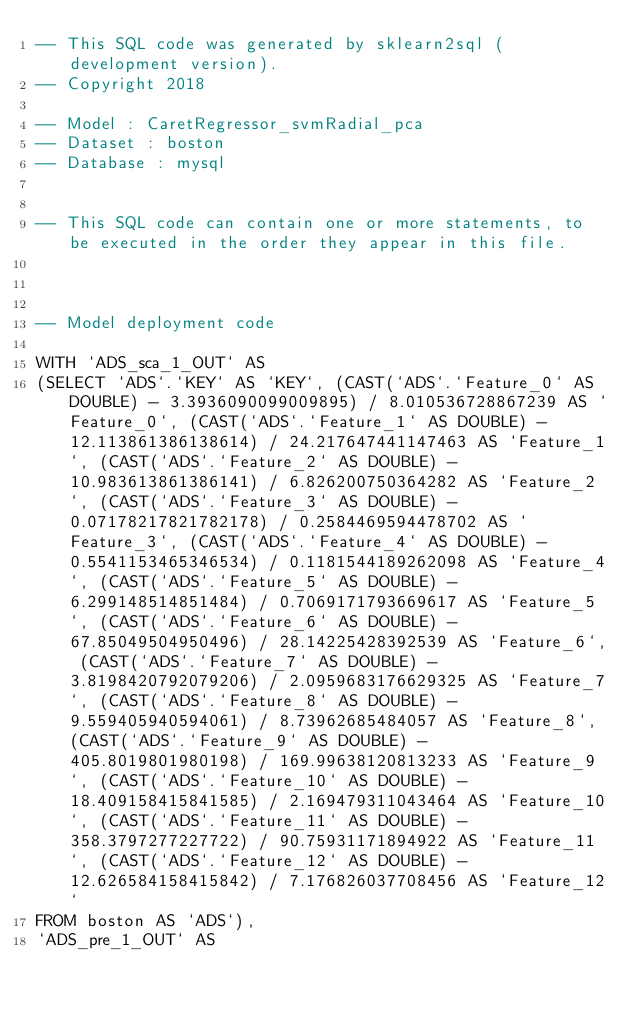Convert code to text. <code><loc_0><loc_0><loc_500><loc_500><_SQL_>-- This SQL code was generated by sklearn2sql (development version).
-- Copyright 2018

-- Model : CaretRegressor_svmRadial_pca
-- Dataset : boston
-- Database : mysql


-- This SQL code can contain one or more statements, to be executed in the order they appear in this file.



-- Model deployment code

WITH `ADS_sca_1_OUT` AS 
(SELECT `ADS`.`KEY` AS `KEY`, (CAST(`ADS`.`Feature_0` AS DOUBLE) - 3.3936090099009895) / 8.010536728867239 AS `Feature_0`, (CAST(`ADS`.`Feature_1` AS DOUBLE) - 12.113861386138614) / 24.217647441147463 AS `Feature_1`, (CAST(`ADS`.`Feature_2` AS DOUBLE) - 10.983613861386141) / 6.826200750364282 AS `Feature_2`, (CAST(`ADS`.`Feature_3` AS DOUBLE) - 0.07178217821782178) / 0.2584469594478702 AS `Feature_3`, (CAST(`ADS`.`Feature_4` AS DOUBLE) - 0.5541153465346534) / 0.1181544189262098 AS `Feature_4`, (CAST(`ADS`.`Feature_5` AS DOUBLE) - 6.299148514851484) / 0.7069171793669617 AS `Feature_5`, (CAST(`ADS`.`Feature_6` AS DOUBLE) - 67.85049504950496) / 28.14225428392539 AS `Feature_6`, (CAST(`ADS`.`Feature_7` AS DOUBLE) - 3.8198420792079206) / 2.0959683176629325 AS `Feature_7`, (CAST(`ADS`.`Feature_8` AS DOUBLE) - 9.559405940594061) / 8.73962685484057 AS `Feature_8`, (CAST(`ADS`.`Feature_9` AS DOUBLE) - 405.8019801980198) / 169.99638120813233 AS `Feature_9`, (CAST(`ADS`.`Feature_10` AS DOUBLE) - 18.409158415841585) / 2.169479311043464 AS `Feature_10`, (CAST(`ADS`.`Feature_11` AS DOUBLE) - 358.3797277227722) / 90.75931171894922 AS `Feature_11`, (CAST(`ADS`.`Feature_12` AS DOUBLE) - 12.626584158415842) / 7.176826037708456 AS `Feature_12` 
FROM boston AS `ADS`), 
`ADS_pre_1_OUT` AS </code> 